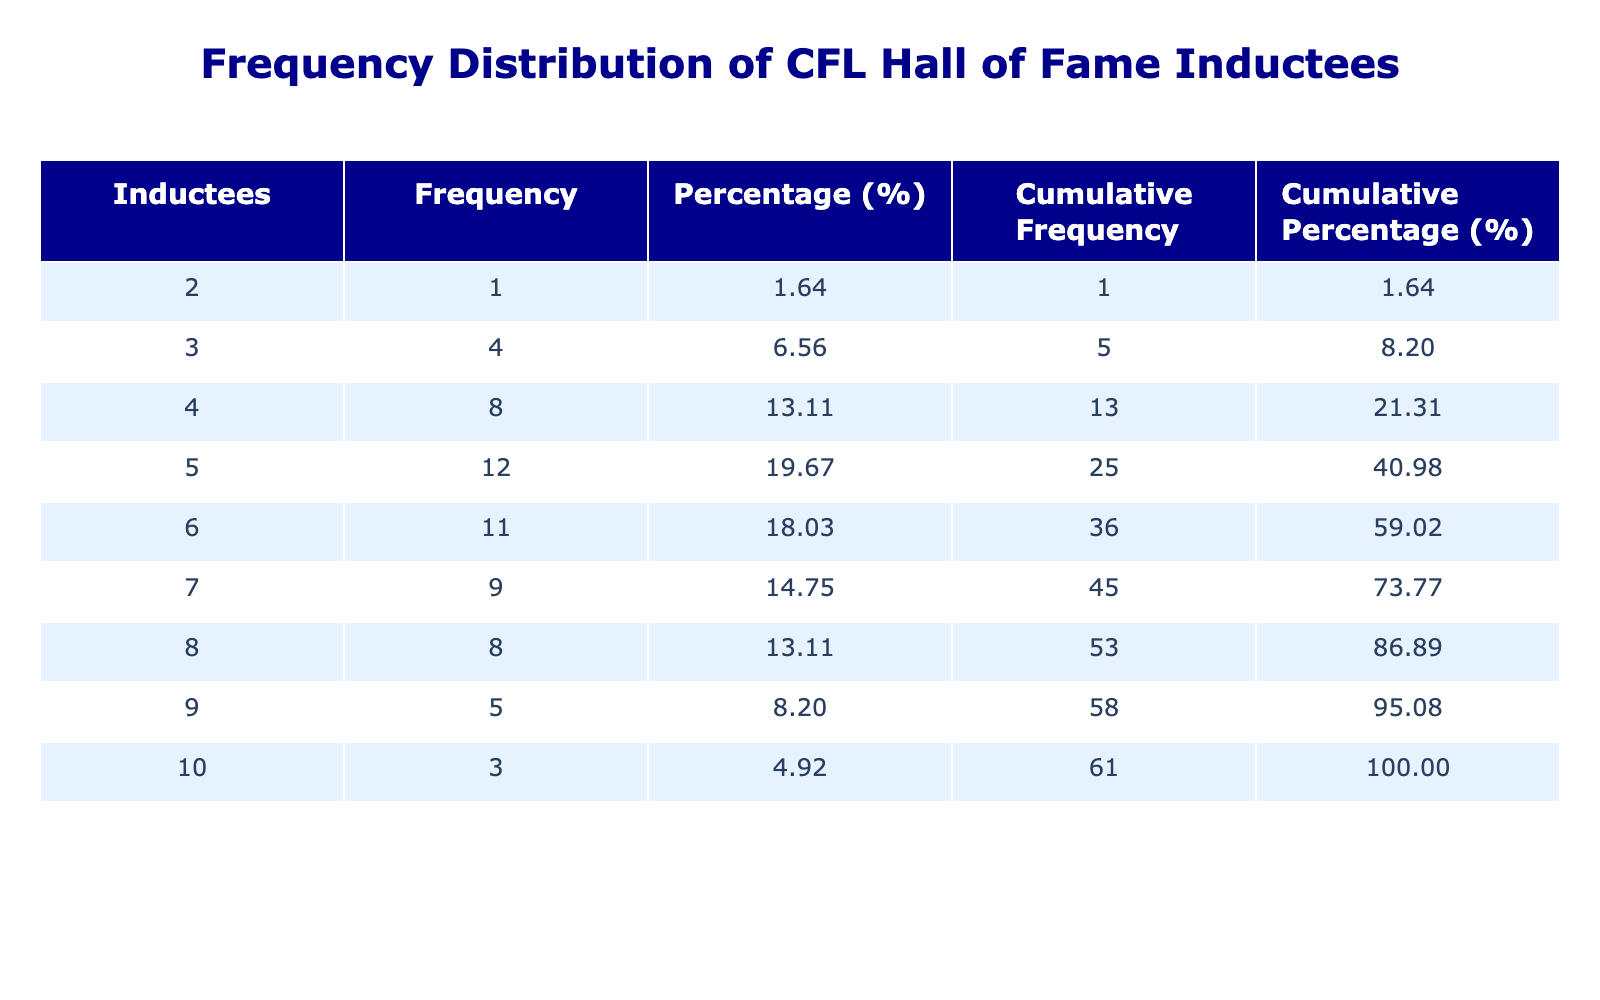What was the highest number of inductees in a single year? By inspecting the 'Inductees' column, the maximum value is 10, which occurs in the years 1987 and 1996.
Answer: 10 What percentage of the years had 7 inductees? There are 8 instances of 7 inductees across 61 years (from 1963 to 2023). To find the percentage, we divide 8 by 61 and multiply by 100, which gives approximately 13.11%.
Answer: 13.11% Is it true that there were fewer than 5 inductees in the year 2020? Looking at the table, the number of inductees in 2020 is 4, which is indeed less than 5. Therefore, the statement is true.
Answer: Yes What is the average number of inductees over the entire period? The total number of inductees is summed up, yielding 389, across 61 years. The average can be computed by dividing 389 by 61, giving approximately 6.37.
Answer: 6.37 How many years had more than 8 inductees? There are 3 years with more than 8 inductees: 1980, 1987, and 2006, where the counts were 9, 10, and 10 respectively.
Answer: 3 Which year had the lowest number of inductees? Referring to the 'Inductees' column, the minimum value is 2, which occurred in 1967.
Answer: 1967 